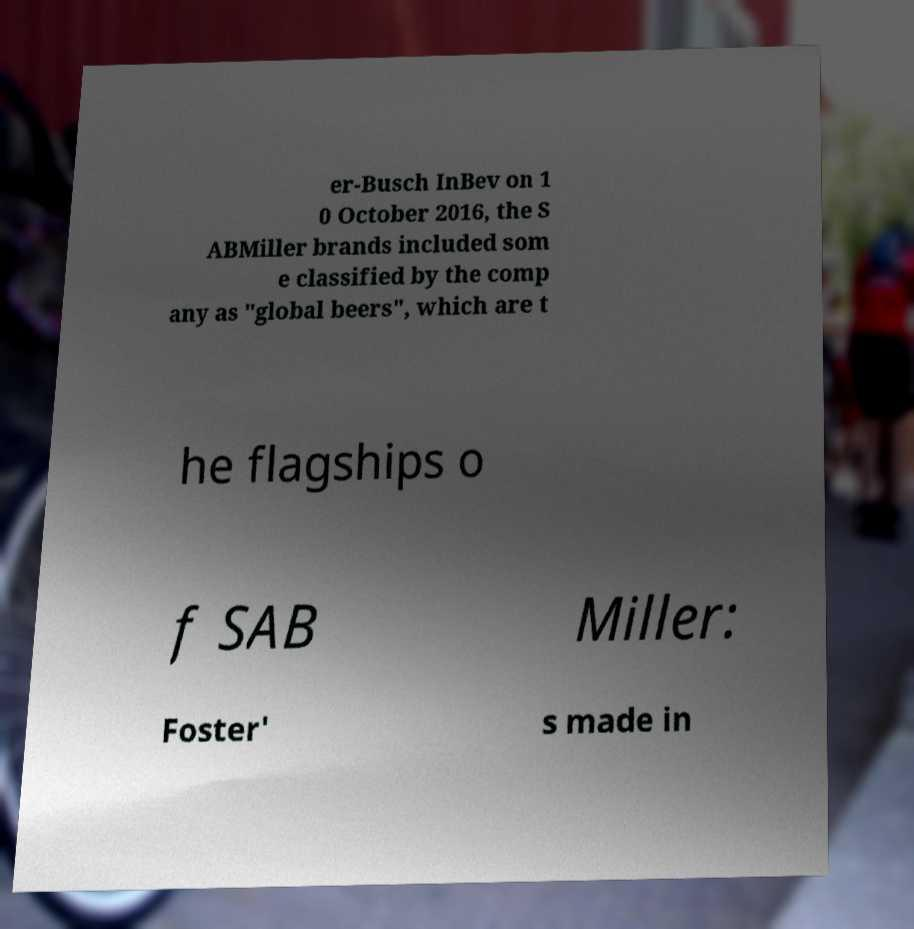Can you accurately transcribe the text from the provided image for me? er-Busch InBev on 1 0 October 2016, the S ABMiller brands included som e classified by the comp any as "global beers", which are t he flagships o f SAB Miller: Foster' s made in 